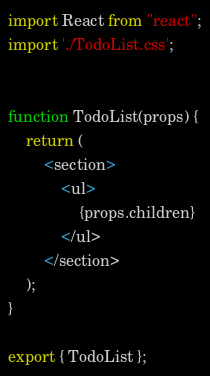<code> <loc_0><loc_0><loc_500><loc_500><_JavaScript_>import React from "react";
import './TodoList.css';


function TodoList(props) { 
    return (
        <section>
            <ul>
                {props.children}
            </ul>
        </section>
    );
}

export { TodoList };</code> 